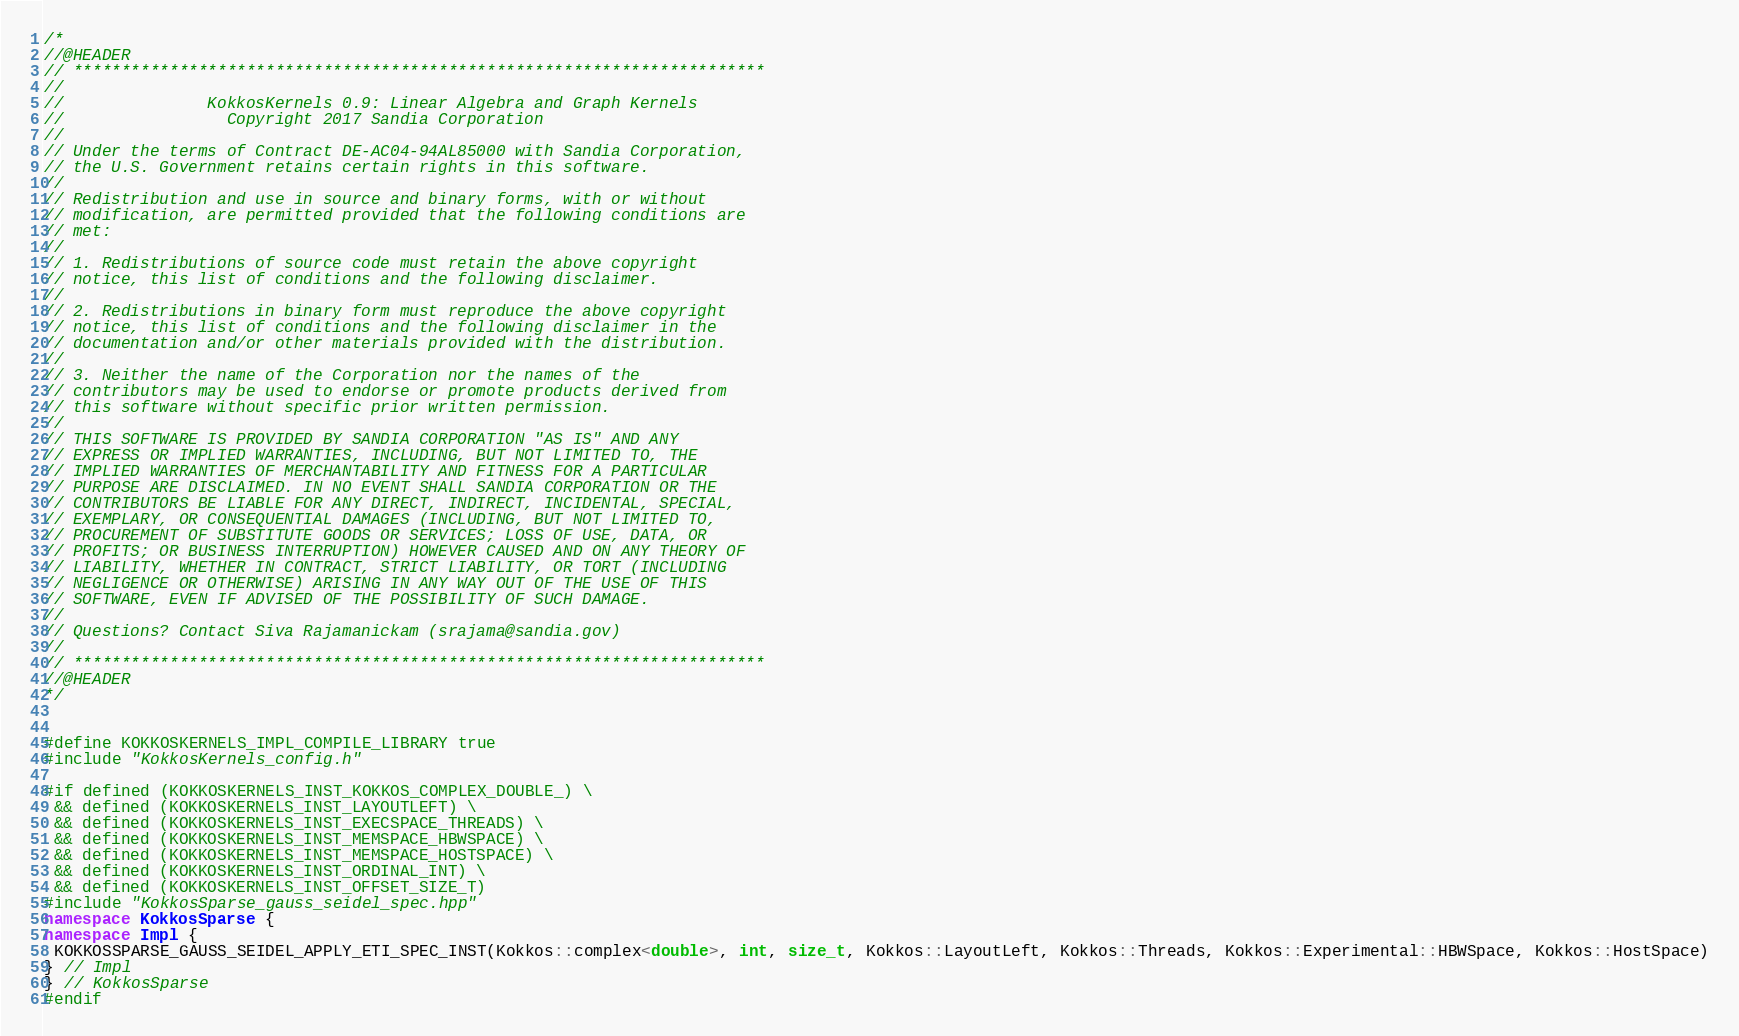Convert code to text. <code><loc_0><loc_0><loc_500><loc_500><_C++_>/*
//@HEADER
// ************************************************************************
//
//               KokkosKernels 0.9: Linear Algebra and Graph Kernels
//                 Copyright 2017 Sandia Corporation
//
// Under the terms of Contract DE-AC04-94AL85000 with Sandia Corporation,
// the U.S. Government retains certain rights in this software.
//
// Redistribution and use in source and binary forms, with or without
// modification, are permitted provided that the following conditions are
// met:
//
// 1. Redistributions of source code must retain the above copyright
// notice, this list of conditions and the following disclaimer.
//
// 2. Redistributions in binary form must reproduce the above copyright
// notice, this list of conditions and the following disclaimer in the
// documentation and/or other materials provided with the distribution.
//
// 3. Neither the name of the Corporation nor the names of the
// contributors may be used to endorse or promote products derived from
// this software without specific prior written permission.
//
// THIS SOFTWARE IS PROVIDED BY SANDIA CORPORATION "AS IS" AND ANY
// EXPRESS OR IMPLIED WARRANTIES, INCLUDING, BUT NOT LIMITED TO, THE
// IMPLIED WARRANTIES OF MERCHANTABILITY AND FITNESS FOR A PARTICULAR
// PURPOSE ARE DISCLAIMED. IN NO EVENT SHALL SANDIA CORPORATION OR THE
// CONTRIBUTORS BE LIABLE FOR ANY DIRECT, INDIRECT, INCIDENTAL, SPECIAL,
// EXEMPLARY, OR CONSEQUENTIAL DAMAGES (INCLUDING, BUT NOT LIMITED TO,
// PROCUREMENT OF SUBSTITUTE GOODS OR SERVICES; LOSS OF USE, DATA, OR
// PROFITS; OR BUSINESS INTERRUPTION) HOWEVER CAUSED AND ON ANY THEORY OF
// LIABILITY, WHETHER IN CONTRACT, STRICT LIABILITY, OR TORT (INCLUDING
// NEGLIGENCE OR OTHERWISE) ARISING IN ANY WAY OUT OF THE USE OF THIS
// SOFTWARE, EVEN IF ADVISED OF THE POSSIBILITY OF SUCH DAMAGE.
//
// Questions? Contact Siva Rajamanickam (srajama@sandia.gov)
//
// ************************************************************************
//@HEADER
*/


#define KOKKOSKERNELS_IMPL_COMPILE_LIBRARY true
#include "KokkosKernels_config.h"

#if defined (KOKKOSKERNELS_INST_KOKKOS_COMPLEX_DOUBLE_) \
 && defined (KOKKOSKERNELS_INST_LAYOUTLEFT) \
 && defined (KOKKOSKERNELS_INST_EXECSPACE_THREADS) \
 && defined (KOKKOSKERNELS_INST_MEMSPACE_HBWSPACE) \
 && defined (KOKKOSKERNELS_INST_MEMSPACE_HOSTSPACE) \
 && defined (KOKKOSKERNELS_INST_ORDINAL_INT) \
 && defined (KOKKOSKERNELS_INST_OFFSET_SIZE_T) 
#include "KokkosSparse_gauss_seidel_spec.hpp"
namespace KokkosSparse {
namespace Impl {
 KOKKOSSPARSE_GAUSS_SEIDEL_APPLY_ETI_SPEC_INST(Kokkos::complex<double>, int, size_t, Kokkos::LayoutLeft, Kokkos::Threads, Kokkos::Experimental::HBWSpace, Kokkos::HostSpace)
} // Impl
} // KokkosSparse
#endif
</code> 